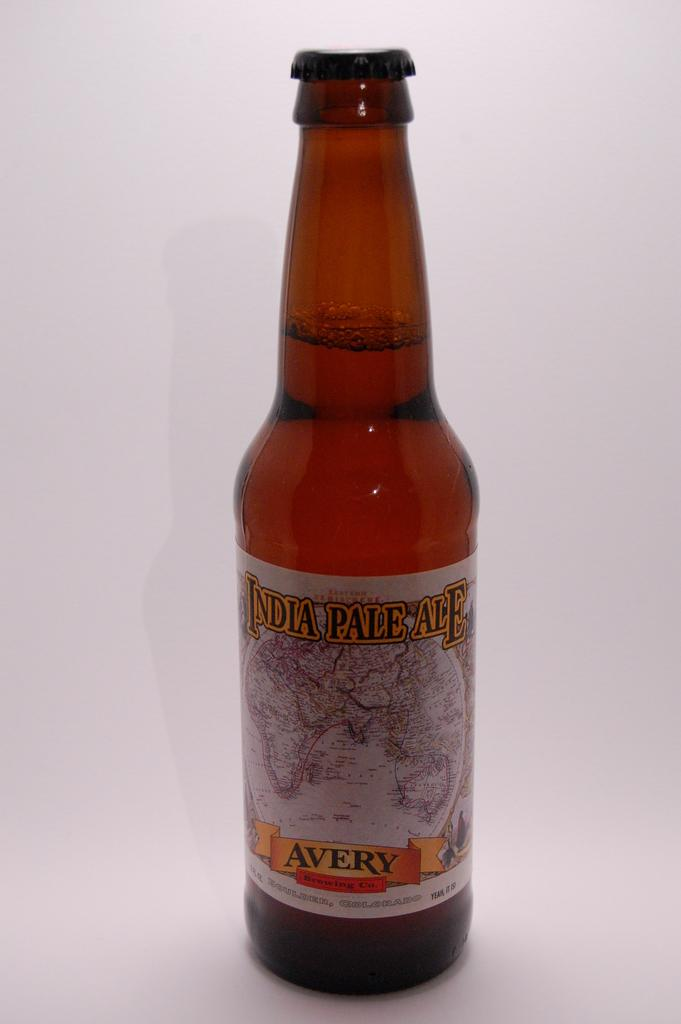<image>
Describe the image concisely. A bottle of India Pale Ale by the Avery Brewing Co. is shown. 